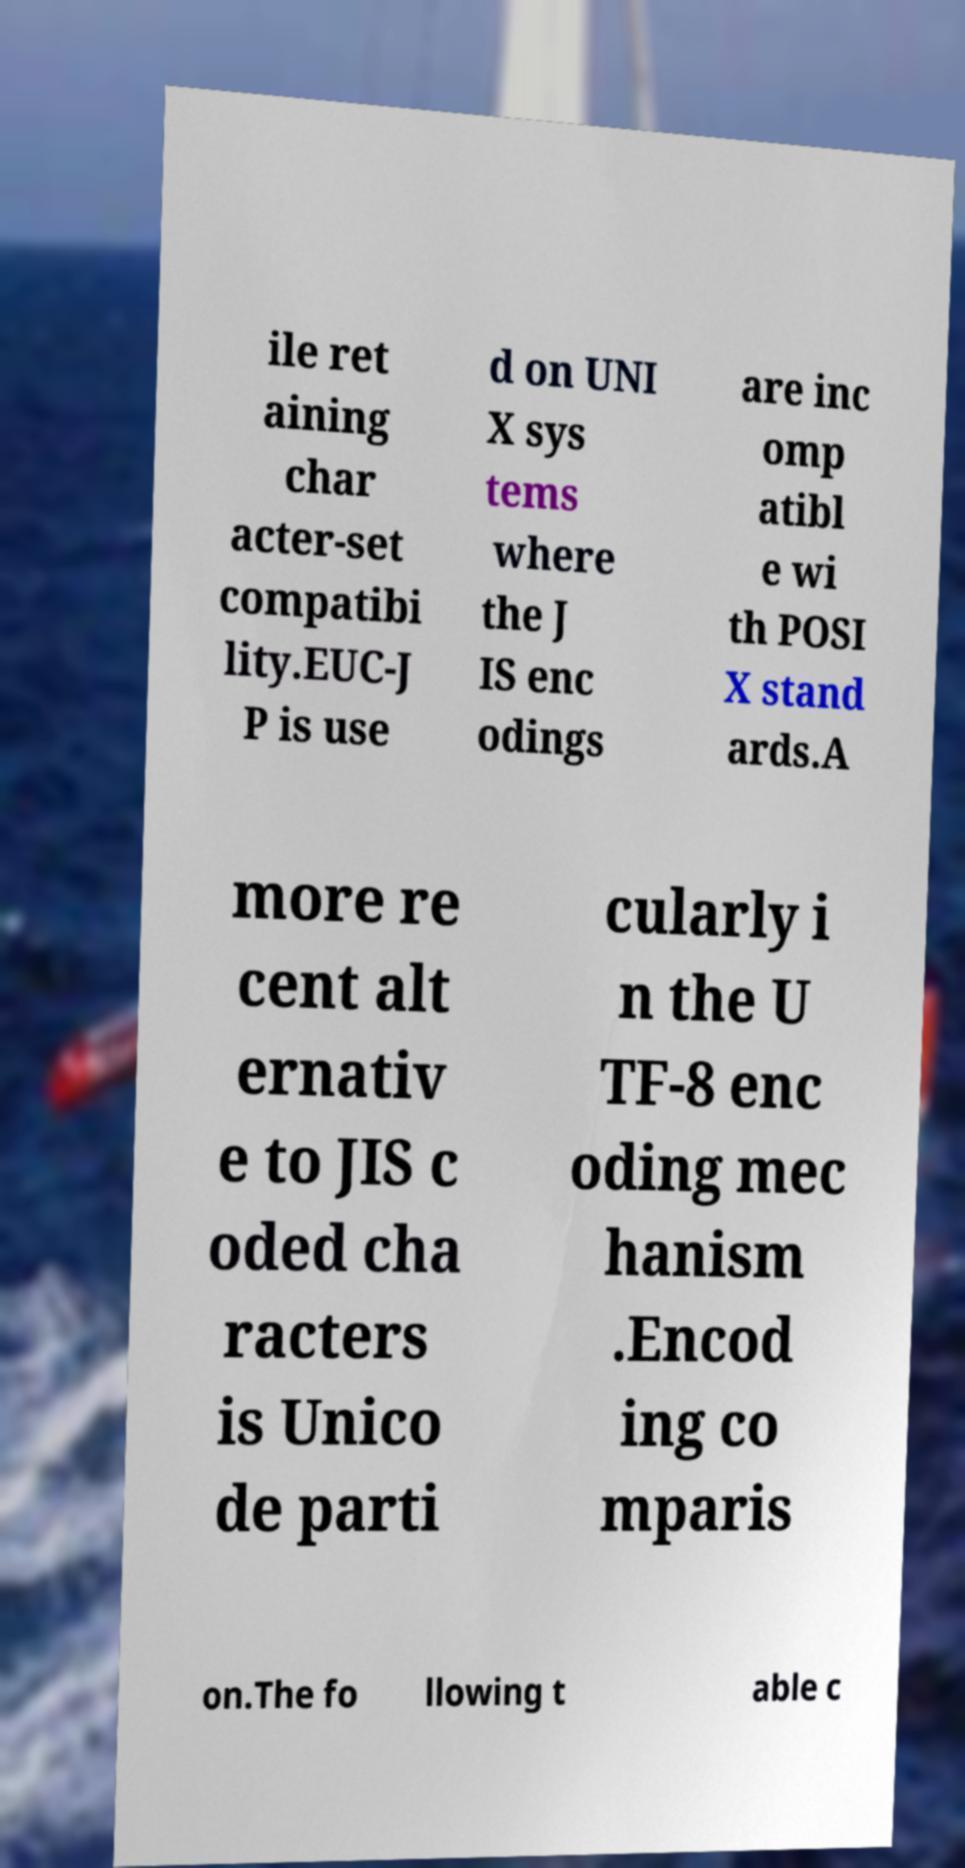There's text embedded in this image that I need extracted. Can you transcribe it verbatim? ile ret aining char acter-set compatibi lity.EUC-J P is use d on UNI X sys tems where the J IS enc odings are inc omp atibl e wi th POSI X stand ards.A more re cent alt ernativ e to JIS c oded cha racters is Unico de parti cularly i n the U TF-8 enc oding mec hanism .Encod ing co mparis on.The fo llowing t able c 